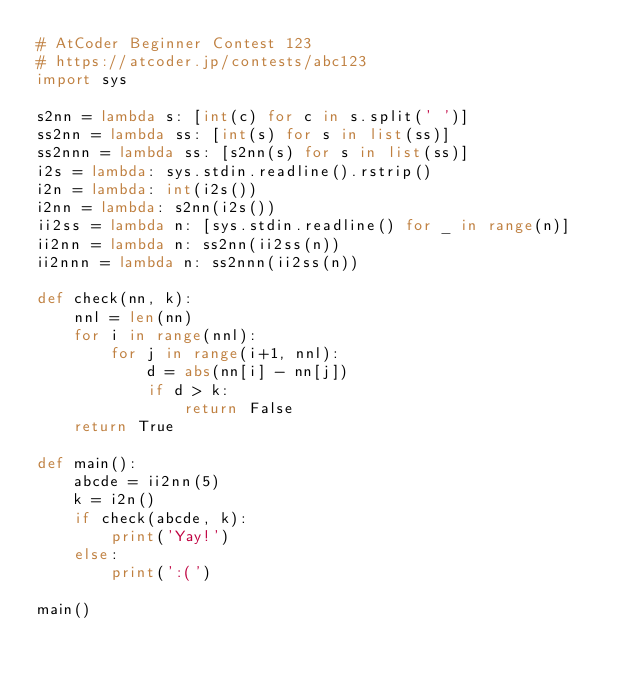Convert code to text. <code><loc_0><loc_0><loc_500><loc_500><_Python_># AtCoder Beginner Contest 123
# https://atcoder.jp/contests/abc123
import sys

s2nn = lambda s: [int(c) for c in s.split(' ')]
ss2nn = lambda ss: [int(s) for s in list(ss)]
ss2nnn = lambda ss: [s2nn(s) for s in list(ss)]
i2s = lambda: sys.stdin.readline().rstrip()
i2n = lambda: int(i2s())
i2nn = lambda: s2nn(i2s())
ii2ss = lambda n: [sys.stdin.readline() for _ in range(n)]
ii2nn = lambda n: ss2nn(ii2ss(n))
ii2nnn = lambda n: ss2nnn(ii2ss(n))

def check(nn, k):
    nnl = len(nn)
    for i in range(nnl):
        for j in range(i+1, nnl):
            d = abs(nn[i] - nn[j])
            if d > k:
                return False
    return True

def main():
    abcde = ii2nn(5)
    k = i2n()
    if check(abcde, k):
        print('Yay!')
    else:
        print(':(')

main()</code> 